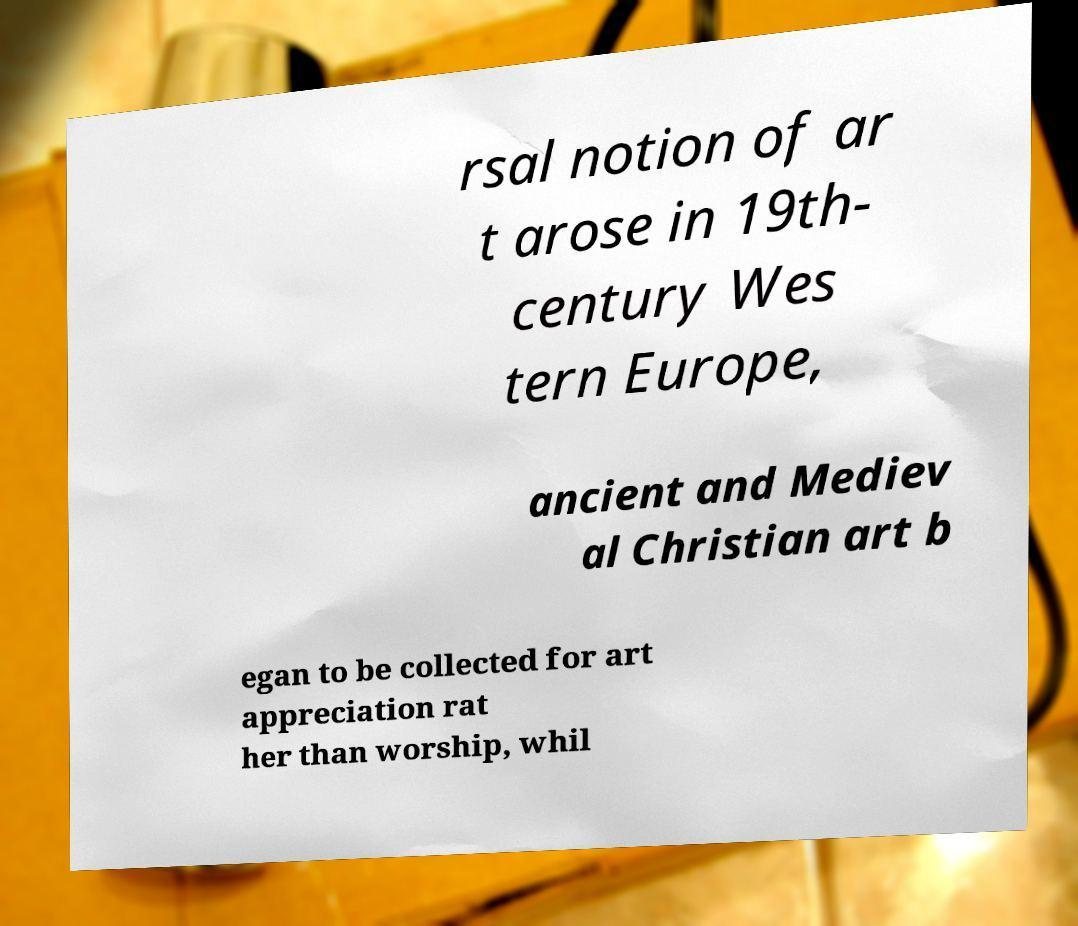There's text embedded in this image that I need extracted. Can you transcribe it verbatim? rsal notion of ar t arose in 19th- century Wes tern Europe, ancient and Mediev al Christian art b egan to be collected for art appreciation rat her than worship, whil 